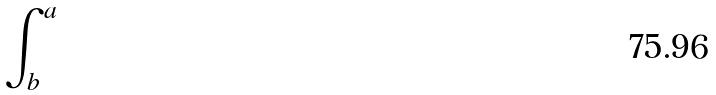<formula> <loc_0><loc_0><loc_500><loc_500>\int _ { b } ^ { a }</formula> 